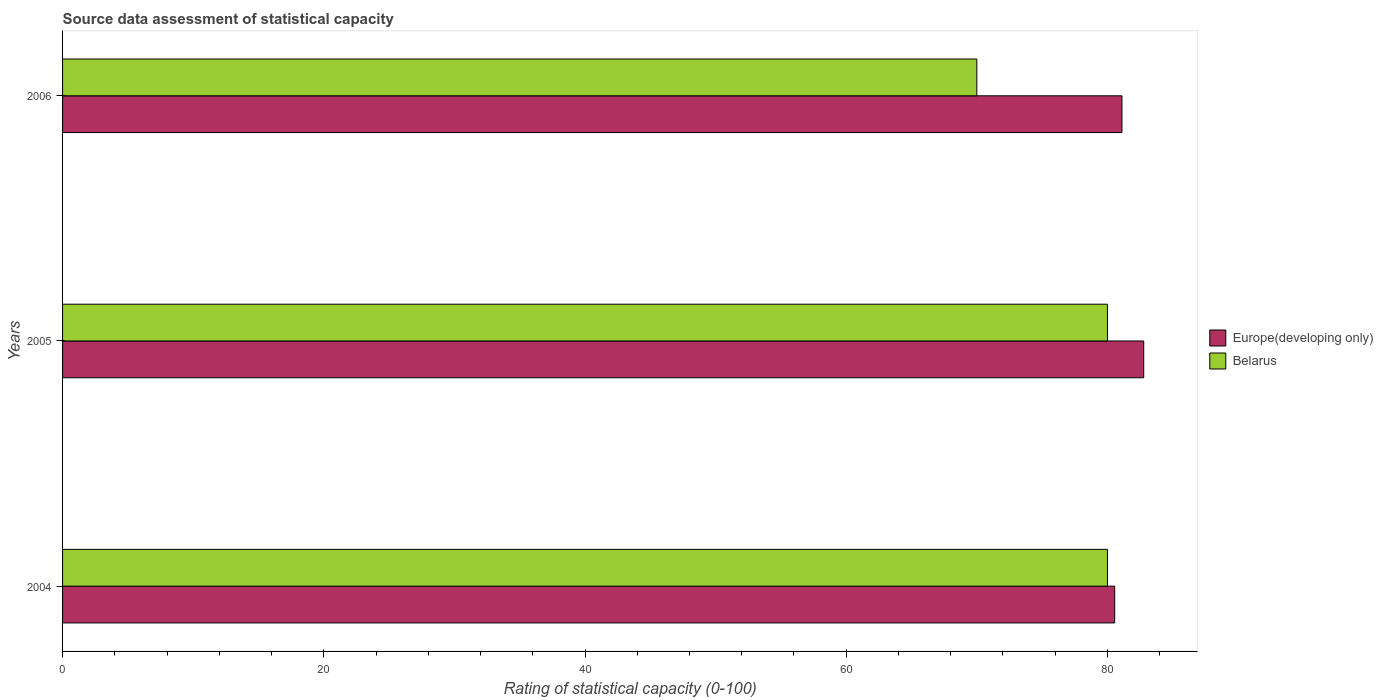How many different coloured bars are there?
Your answer should be compact. 2. Are the number of bars on each tick of the Y-axis equal?
Provide a short and direct response. Yes. How many bars are there on the 3rd tick from the top?
Your response must be concise. 2. What is the rating of statistical capacity in Belarus in 2004?
Keep it short and to the point. 80. Across all years, what is the maximum rating of statistical capacity in Europe(developing only)?
Your answer should be very brief. 82.78. Across all years, what is the minimum rating of statistical capacity in Europe(developing only)?
Give a very brief answer. 80.56. In which year was the rating of statistical capacity in Europe(developing only) minimum?
Offer a very short reply. 2004. What is the total rating of statistical capacity in Belarus in the graph?
Offer a terse response. 230. What is the difference between the rating of statistical capacity in Europe(developing only) in 2004 and that in 2005?
Your answer should be very brief. -2.22. What is the difference between the rating of statistical capacity in Europe(developing only) in 2006 and the rating of statistical capacity in Belarus in 2005?
Ensure brevity in your answer.  1.11. What is the average rating of statistical capacity in Europe(developing only) per year?
Your answer should be very brief. 81.48. In the year 2005, what is the difference between the rating of statistical capacity in Belarus and rating of statistical capacity in Europe(developing only)?
Make the answer very short. -2.78. In how many years, is the rating of statistical capacity in Belarus greater than 4 ?
Make the answer very short. 3. What is the ratio of the rating of statistical capacity in Belarus in 2005 to that in 2006?
Keep it short and to the point. 1.14. Is the difference between the rating of statistical capacity in Belarus in 2004 and 2005 greater than the difference between the rating of statistical capacity in Europe(developing only) in 2004 and 2005?
Your answer should be compact. Yes. What is the difference between the highest and the second highest rating of statistical capacity in Europe(developing only)?
Keep it short and to the point. 1.67. What is the difference between the highest and the lowest rating of statistical capacity in Belarus?
Offer a terse response. 10. In how many years, is the rating of statistical capacity in Europe(developing only) greater than the average rating of statistical capacity in Europe(developing only) taken over all years?
Your response must be concise. 1. Is the sum of the rating of statistical capacity in Europe(developing only) in 2004 and 2005 greater than the maximum rating of statistical capacity in Belarus across all years?
Provide a succinct answer. Yes. What does the 2nd bar from the top in 2006 represents?
Offer a terse response. Europe(developing only). What does the 2nd bar from the bottom in 2005 represents?
Ensure brevity in your answer.  Belarus. Are all the bars in the graph horizontal?
Give a very brief answer. Yes. What is the difference between two consecutive major ticks on the X-axis?
Give a very brief answer. 20. Are the values on the major ticks of X-axis written in scientific E-notation?
Your answer should be compact. No. Does the graph contain any zero values?
Offer a very short reply. No. What is the title of the graph?
Your answer should be compact. Source data assessment of statistical capacity. Does "France" appear as one of the legend labels in the graph?
Give a very brief answer. No. What is the label or title of the X-axis?
Provide a succinct answer. Rating of statistical capacity (0-100). What is the Rating of statistical capacity (0-100) of Europe(developing only) in 2004?
Provide a succinct answer. 80.56. What is the Rating of statistical capacity (0-100) in Europe(developing only) in 2005?
Offer a terse response. 82.78. What is the Rating of statistical capacity (0-100) of Europe(developing only) in 2006?
Offer a very short reply. 81.11. Across all years, what is the maximum Rating of statistical capacity (0-100) in Europe(developing only)?
Make the answer very short. 82.78. Across all years, what is the maximum Rating of statistical capacity (0-100) of Belarus?
Keep it short and to the point. 80. Across all years, what is the minimum Rating of statistical capacity (0-100) of Europe(developing only)?
Provide a short and direct response. 80.56. Across all years, what is the minimum Rating of statistical capacity (0-100) of Belarus?
Your answer should be compact. 70. What is the total Rating of statistical capacity (0-100) of Europe(developing only) in the graph?
Make the answer very short. 244.44. What is the total Rating of statistical capacity (0-100) in Belarus in the graph?
Your answer should be compact. 230. What is the difference between the Rating of statistical capacity (0-100) of Europe(developing only) in 2004 and that in 2005?
Offer a very short reply. -2.22. What is the difference between the Rating of statistical capacity (0-100) of Belarus in 2004 and that in 2005?
Your answer should be very brief. 0. What is the difference between the Rating of statistical capacity (0-100) in Europe(developing only) in 2004 and that in 2006?
Provide a succinct answer. -0.56. What is the difference between the Rating of statistical capacity (0-100) in Europe(developing only) in 2005 and that in 2006?
Offer a very short reply. 1.67. What is the difference between the Rating of statistical capacity (0-100) in Europe(developing only) in 2004 and the Rating of statistical capacity (0-100) in Belarus in 2005?
Your response must be concise. 0.56. What is the difference between the Rating of statistical capacity (0-100) in Europe(developing only) in 2004 and the Rating of statistical capacity (0-100) in Belarus in 2006?
Ensure brevity in your answer.  10.56. What is the difference between the Rating of statistical capacity (0-100) in Europe(developing only) in 2005 and the Rating of statistical capacity (0-100) in Belarus in 2006?
Give a very brief answer. 12.78. What is the average Rating of statistical capacity (0-100) of Europe(developing only) per year?
Give a very brief answer. 81.48. What is the average Rating of statistical capacity (0-100) in Belarus per year?
Provide a short and direct response. 76.67. In the year 2004, what is the difference between the Rating of statistical capacity (0-100) in Europe(developing only) and Rating of statistical capacity (0-100) in Belarus?
Provide a succinct answer. 0.56. In the year 2005, what is the difference between the Rating of statistical capacity (0-100) of Europe(developing only) and Rating of statistical capacity (0-100) of Belarus?
Your answer should be compact. 2.78. In the year 2006, what is the difference between the Rating of statistical capacity (0-100) of Europe(developing only) and Rating of statistical capacity (0-100) of Belarus?
Ensure brevity in your answer.  11.11. What is the ratio of the Rating of statistical capacity (0-100) in Europe(developing only) in 2004 to that in 2005?
Ensure brevity in your answer.  0.97. What is the ratio of the Rating of statistical capacity (0-100) in Belarus in 2004 to that in 2005?
Your answer should be compact. 1. What is the ratio of the Rating of statistical capacity (0-100) of Europe(developing only) in 2004 to that in 2006?
Your response must be concise. 0.99. What is the ratio of the Rating of statistical capacity (0-100) of Europe(developing only) in 2005 to that in 2006?
Keep it short and to the point. 1.02. What is the difference between the highest and the second highest Rating of statistical capacity (0-100) of Europe(developing only)?
Your response must be concise. 1.67. What is the difference between the highest and the second highest Rating of statistical capacity (0-100) in Belarus?
Offer a very short reply. 0. What is the difference between the highest and the lowest Rating of statistical capacity (0-100) of Europe(developing only)?
Keep it short and to the point. 2.22. 